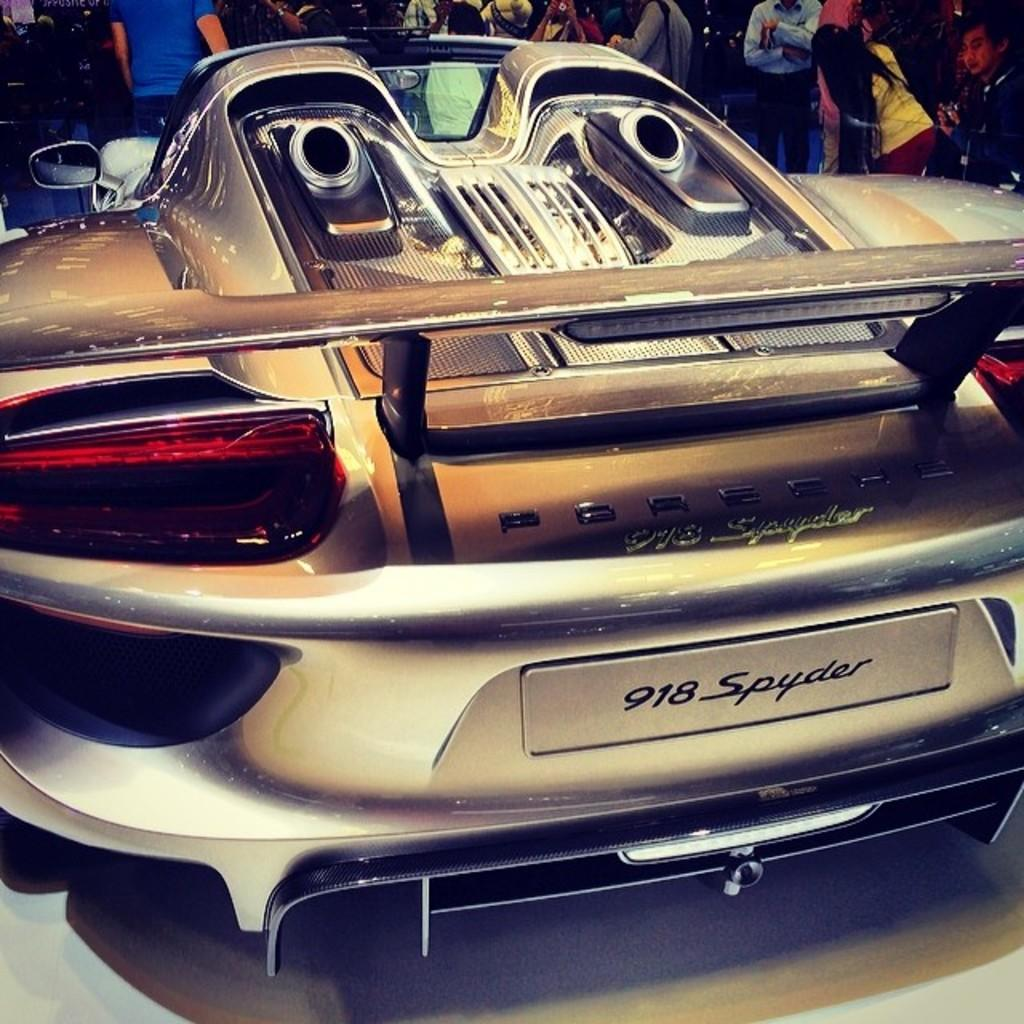What is the main subject of the image? The main subject of the image is a car. Where is the car located in the image? The car is on the floor in the image. Are there any people present in the image? Yes, there are people standing in front of the car. How many chairs can be seen in the image? There are no chairs present in the image. What type of ball is being used by the people in the image? There are no balls present in the image. 